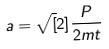<formula> <loc_0><loc_0><loc_500><loc_500>a = \sqrt { [ } 2 ] { \frac { P } { 2 m t } }</formula> 